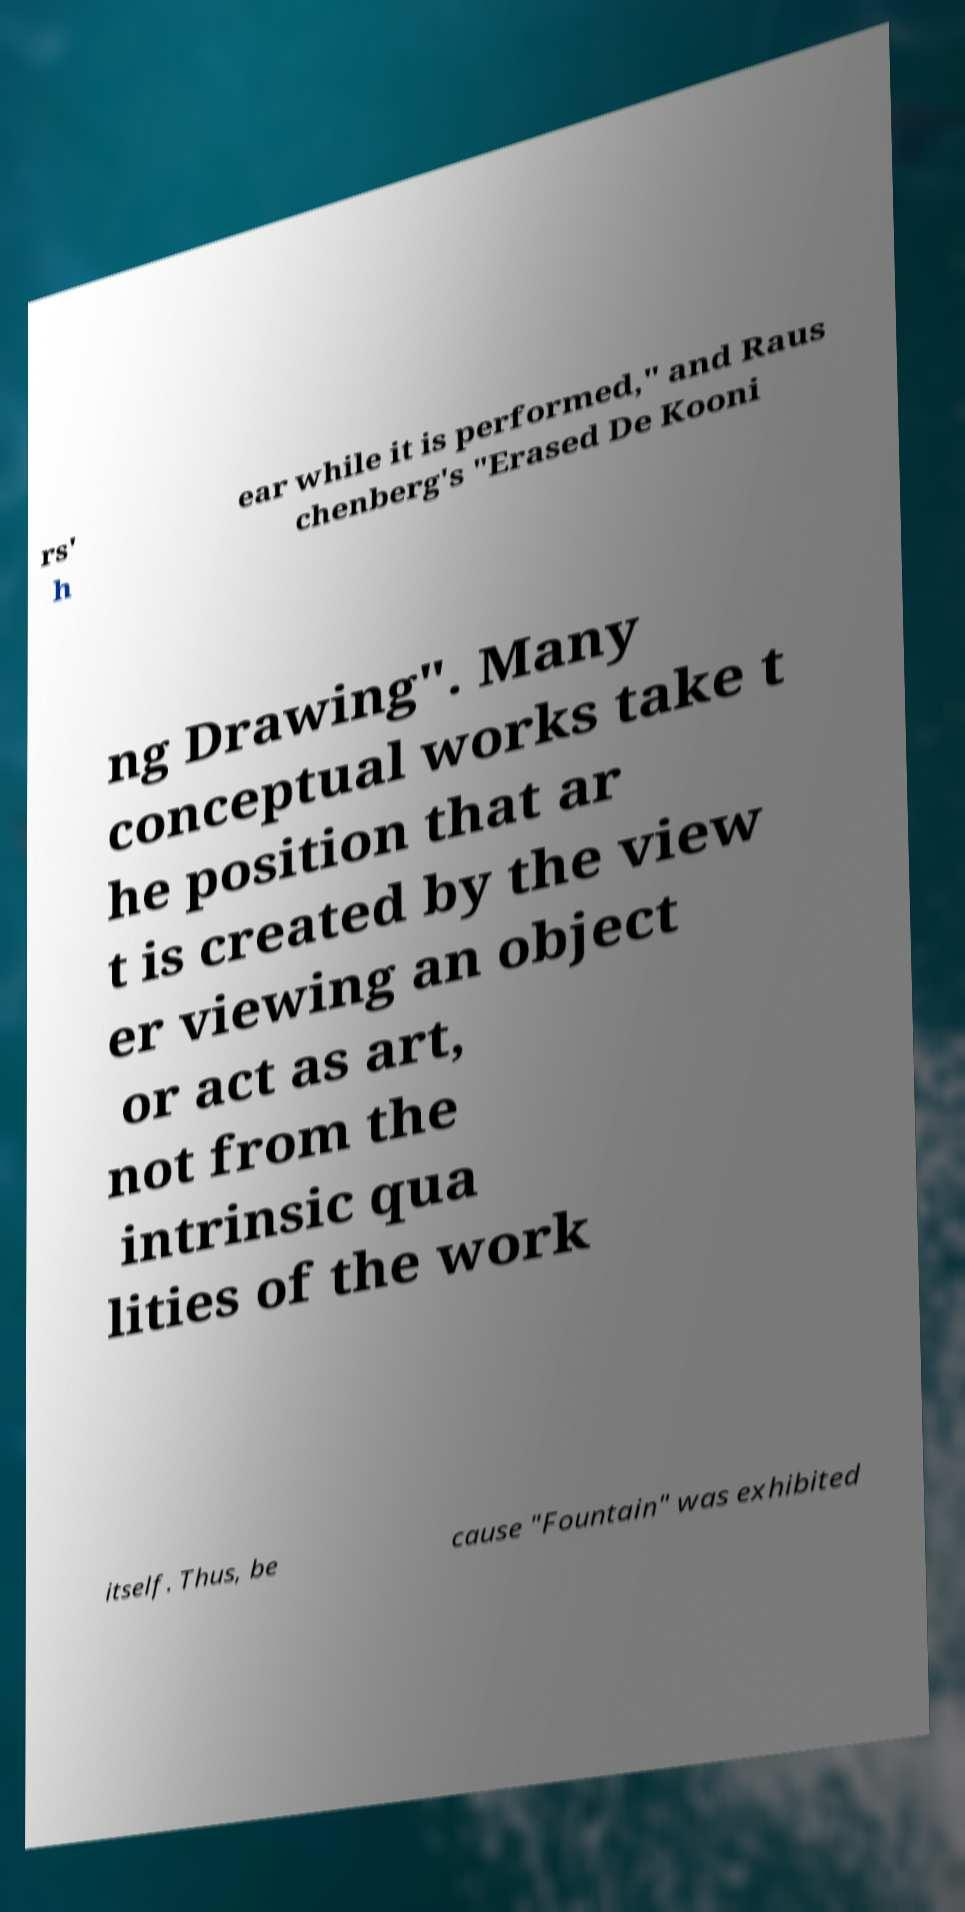Could you assist in decoding the text presented in this image and type it out clearly? rs' h ear while it is performed," and Raus chenberg's "Erased De Kooni ng Drawing". Many conceptual works take t he position that ar t is created by the view er viewing an object or act as art, not from the intrinsic qua lities of the work itself. Thus, be cause "Fountain" was exhibited 